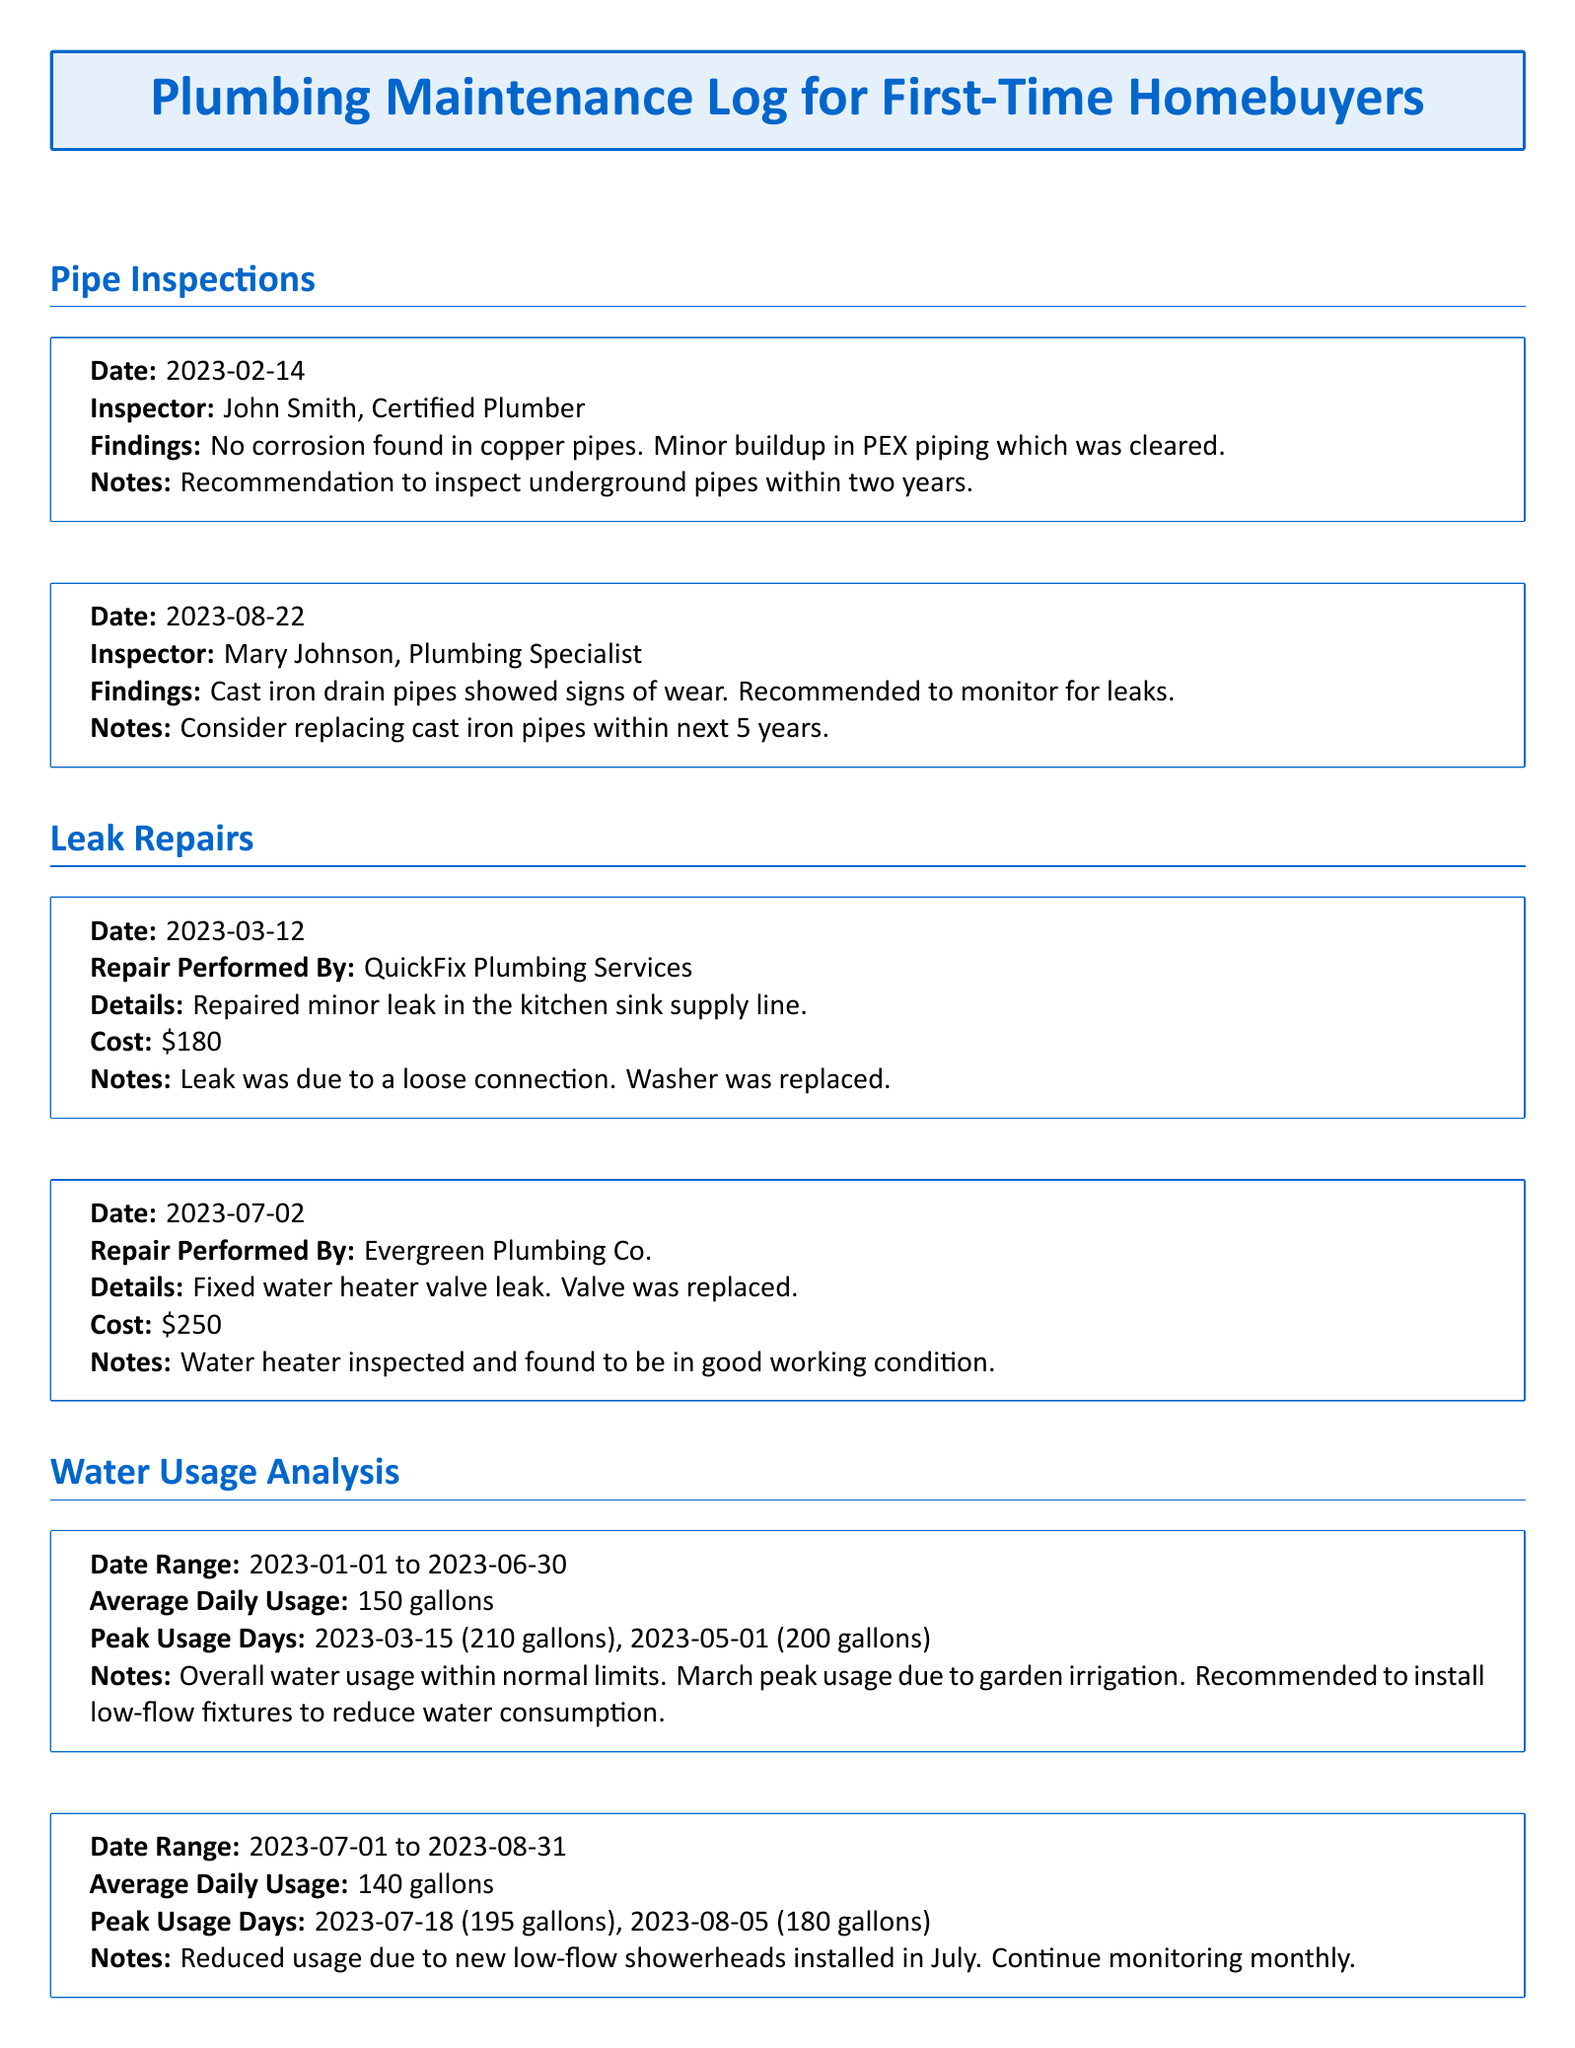What date was the last pipe inspection? The last pipe inspection was performed on August 22, 2023.
Answer: August 22, 2023 Who performed the second leak repair? The second leak repair was performed by Evergreen Plumbing Co.
Answer: Evergreen Plumbing Co What was the cost of the minor leak repair in the kitchen? The cost of the minor leak repair in the kitchen sink was $180.
Answer: $180 What was the average daily water usage during the first half of 2023? The average daily water usage from January 1 to June 30, 2023, was 150 gallons.
Answer: 150 gallons What are the notes associated with the first pipe inspection? The notes for the first pipe inspection recommend inspecting underground pipes within two years.
Answer: Inspect underground pipes within two years What findings were reported during the pipe inspection on February 14, 2023? The findings reported no corrosion found in copper pipes and minor buildup in PEX piping.
Answer: No corrosion found in copper pipes How many gallons did the peak usage occur on March 15, 2023? The peak usage on March 15, 2023, was 210 gallons.
Answer: 210 gallons What was recommended to reduce water consumption? It was recommended to install low-flow fixtures to reduce water consumption.
Answer: Install low-flow fixtures What is the recommendation regarding the cast iron drain pipes? The recommendation is to consider replacing cast iron pipes within the next 5 years.
Answer: Replace cast iron pipes within next 5 years 